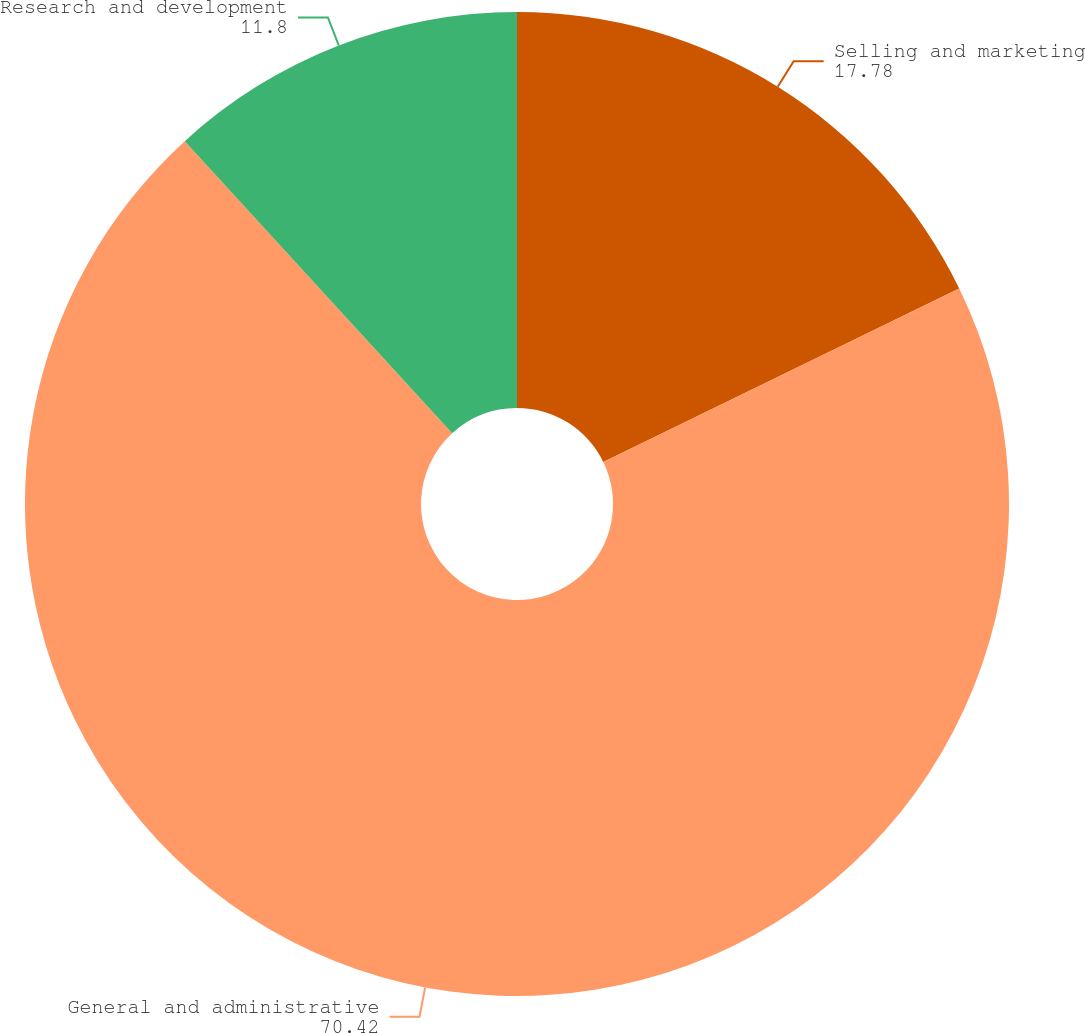<chart> <loc_0><loc_0><loc_500><loc_500><pie_chart><fcel>Selling and marketing<fcel>General and administrative<fcel>Research and development<nl><fcel>17.78%<fcel>70.42%<fcel>11.8%<nl></chart> 